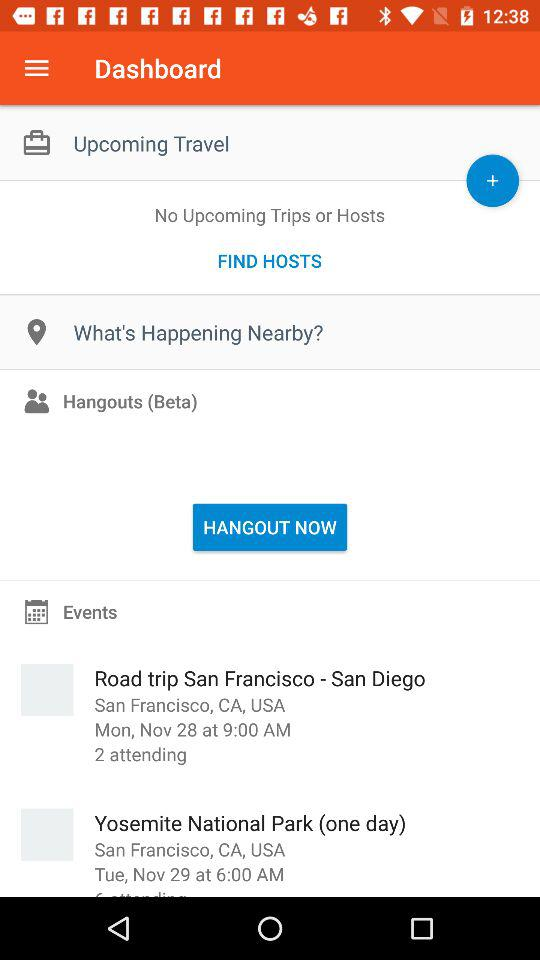How many people are attending the trip to Yosemite National Park?
When the provided information is insufficient, respond with <no answer>. <no answer> 